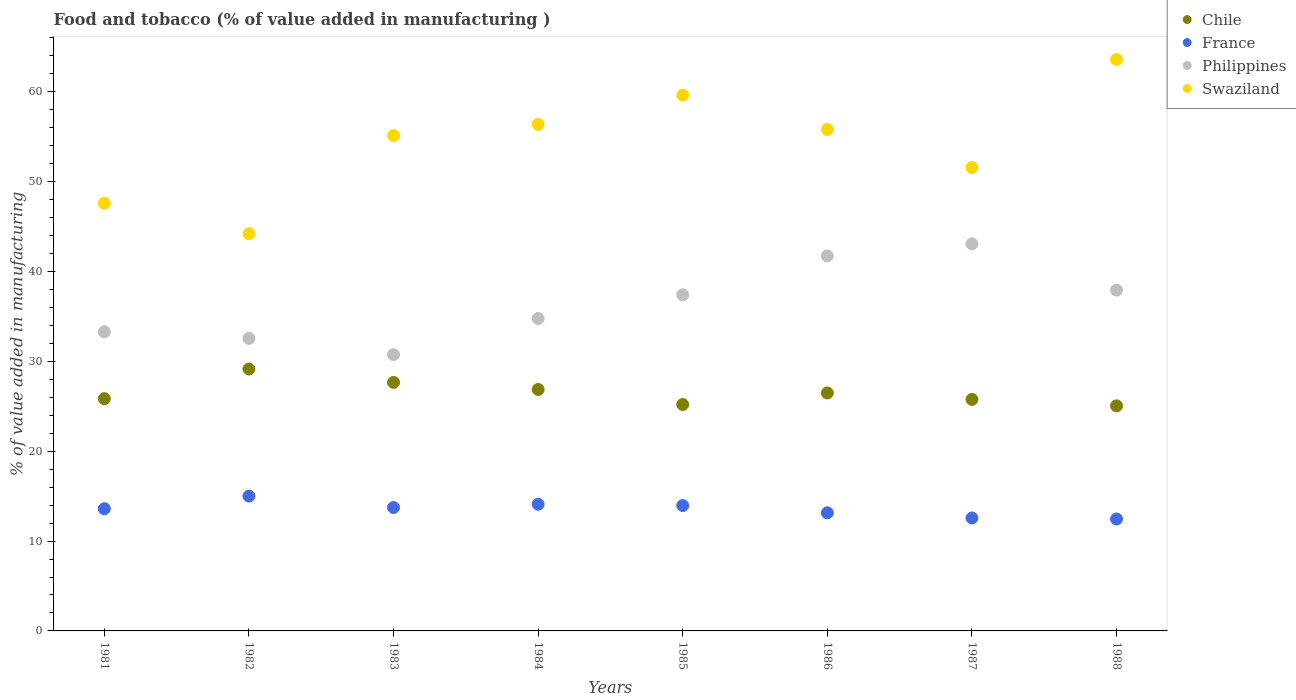How many different coloured dotlines are there?
Keep it short and to the point. 4. What is the value added in manufacturing food and tobacco in Chile in 1981?
Your answer should be compact. 25.85. Across all years, what is the maximum value added in manufacturing food and tobacco in Chile?
Offer a terse response. 29.15. Across all years, what is the minimum value added in manufacturing food and tobacco in France?
Keep it short and to the point. 12.45. In which year was the value added in manufacturing food and tobacco in Chile minimum?
Your answer should be compact. 1988. What is the total value added in manufacturing food and tobacco in France in the graph?
Provide a succinct answer. 108.56. What is the difference between the value added in manufacturing food and tobacco in France in 1986 and that in 1987?
Offer a very short reply. 0.58. What is the difference between the value added in manufacturing food and tobacco in France in 1984 and the value added in manufacturing food and tobacco in Swaziland in 1986?
Offer a terse response. -41.71. What is the average value added in manufacturing food and tobacco in Philippines per year?
Offer a very short reply. 36.44. In the year 1988, what is the difference between the value added in manufacturing food and tobacco in France and value added in manufacturing food and tobacco in Swaziland?
Keep it short and to the point. -51.13. What is the ratio of the value added in manufacturing food and tobacco in Chile in 1982 to that in 1983?
Your response must be concise. 1.05. What is the difference between the highest and the second highest value added in manufacturing food and tobacco in Philippines?
Make the answer very short. 1.35. What is the difference between the highest and the lowest value added in manufacturing food and tobacco in Chile?
Provide a succinct answer. 4.1. In how many years, is the value added in manufacturing food and tobacco in France greater than the average value added in manufacturing food and tobacco in France taken over all years?
Provide a succinct answer. 5. Is it the case that in every year, the sum of the value added in manufacturing food and tobacco in Swaziland and value added in manufacturing food and tobacco in France  is greater than the sum of value added in manufacturing food and tobacco in Philippines and value added in manufacturing food and tobacco in Chile?
Give a very brief answer. No. How many dotlines are there?
Keep it short and to the point. 4. How many years are there in the graph?
Make the answer very short. 8. How many legend labels are there?
Your answer should be very brief. 4. What is the title of the graph?
Provide a succinct answer. Food and tobacco (% of value added in manufacturing ). What is the label or title of the Y-axis?
Keep it short and to the point. % of value added in manufacturing. What is the % of value added in manufacturing in Chile in 1981?
Keep it short and to the point. 25.85. What is the % of value added in manufacturing of France in 1981?
Your response must be concise. 13.6. What is the % of value added in manufacturing of Philippines in 1981?
Give a very brief answer. 33.29. What is the % of value added in manufacturing of Swaziland in 1981?
Offer a very short reply. 47.6. What is the % of value added in manufacturing in Chile in 1982?
Offer a very short reply. 29.15. What is the % of value added in manufacturing in France in 1982?
Keep it short and to the point. 15.01. What is the % of value added in manufacturing in Philippines in 1982?
Make the answer very short. 32.56. What is the % of value added in manufacturing of Swaziland in 1982?
Provide a succinct answer. 44.2. What is the % of value added in manufacturing of Chile in 1983?
Provide a short and direct response. 27.66. What is the % of value added in manufacturing in France in 1983?
Make the answer very short. 13.73. What is the % of value added in manufacturing in Philippines in 1983?
Provide a succinct answer. 30.75. What is the % of value added in manufacturing in Swaziland in 1983?
Offer a very short reply. 55.12. What is the % of value added in manufacturing of Chile in 1984?
Offer a very short reply. 26.87. What is the % of value added in manufacturing of France in 1984?
Your response must be concise. 14.1. What is the % of value added in manufacturing in Philippines in 1984?
Give a very brief answer. 34.77. What is the % of value added in manufacturing in Swaziland in 1984?
Provide a short and direct response. 56.37. What is the % of value added in manufacturing of Chile in 1985?
Provide a succinct answer. 25.2. What is the % of value added in manufacturing of France in 1985?
Provide a succinct answer. 13.95. What is the % of value added in manufacturing of Philippines in 1985?
Give a very brief answer. 37.41. What is the % of value added in manufacturing in Swaziland in 1985?
Your answer should be compact. 59.63. What is the % of value added in manufacturing in Chile in 1986?
Your answer should be very brief. 26.48. What is the % of value added in manufacturing of France in 1986?
Offer a very short reply. 13.15. What is the % of value added in manufacturing of Philippines in 1986?
Your answer should be very brief. 41.73. What is the % of value added in manufacturing in Swaziland in 1986?
Make the answer very short. 55.81. What is the % of value added in manufacturing of Chile in 1987?
Keep it short and to the point. 25.76. What is the % of value added in manufacturing of France in 1987?
Your answer should be compact. 12.57. What is the % of value added in manufacturing of Philippines in 1987?
Provide a short and direct response. 43.08. What is the % of value added in manufacturing of Swaziland in 1987?
Your response must be concise. 51.57. What is the % of value added in manufacturing of Chile in 1988?
Offer a very short reply. 25.05. What is the % of value added in manufacturing in France in 1988?
Provide a succinct answer. 12.45. What is the % of value added in manufacturing in Philippines in 1988?
Your response must be concise. 37.93. What is the % of value added in manufacturing in Swaziland in 1988?
Provide a succinct answer. 63.59. Across all years, what is the maximum % of value added in manufacturing in Chile?
Your response must be concise. 29.15. Across all years, what is the maximum % of value added in manufacturing in France?
Your answer should be compact. 15.01. Across all years, what is the maximum % of value added in manufacturing of Philippines?
Offer a very short reply. 43.08. Across all years, what is the maximum % of value added in manufacturing in Swaziland?
Provide a succinct answer. 63.59. Across all years, what is the minimum % of value added in manufacturing in Chile?
Offer a very short reply. 25.05. Across all years, what is the minimum % of value added in manufacturing in France?
Provide a succinct answer. 12.45. Across all years, what is the minimum % of value added in manufacturing of Philippines?
Offer a terse response. 30.75. Across all years, what is the minimum % of value added in manufacturing of Swaziland?
Give a very brief answer. 44.2. What is the total % of value added in manufacturing of Chile in the graph?
Keep it short and to the point. 212.02. What is the total % of value added in manufacturing of France in the graph?
Provide a short and direct response. 108.56. What is the total % of value added in manufacturing of Philippines in the graph?
Make the answer very short. 291.52. What is the total % of value added in manufacturing of Swaziland in the graph?
Provide a succinct answer. 433.88. What is the difference between the % of value added in manufacturing of Chile in 1981 and that in 1982?
Keep it short and to the point. -3.3. What is the difference between the % of value added in manufacturing of France in 1981 and that in 1982?
Ensure brevity in your answer.  -1.41. What is the difference between the % of value added in manufacturing in Philippines in 1981 and that in 1982?
Give a very brief answer. 0.73. What is the difference between the % of value added in manufacturing in Swaziland in 1981 and that in 1982?
Provide a short and direct response. 3.4. What is the difference between the % of value added in manufacturing of Chile in 1981 and that in 1983?
Offer a terse response. -1.81. What is the difference between the % of value added in manufacturing in France in 1981 and that in 1983?
Keep it short and to the point. -0.13. What is the difference between the % of value added in manufacturing of Philippines in 1981 and that in 1983?
Provide a succinct answer. 2.55. What is the difference between the % of value added in manufacturing in Swaziland in 1981 and that in 1983?
Your answer should be compact. -7.53. What is the difference between the % of value added in manufacturing in Chile in 1981 and that in 1984?
Ensure brevity in your answer.  -1.02. What is the difference between the % of value added in manufacturing in Philippines in 1981 and that in 1984?
Your answer should be compact. -1.48. What is the difference between the % of value added in manufacturing of Swaziland in 1981 and that in 1984?
Make the answer very short. -8.77. What is the difference between the % of value added in manufacturing of Chile in 1981 and that in 1985?
Ensure brevity in your answer.  0.65. What is the difference between the % of value added in manufacturing in France in 1981 and that in 1985?
Your answer should be very brief. -0.35. What is the difference between the % of value added in manufacturing of Philippines in 1981 and that in 1985?
Ensure brevity in your answer.  -4.11. What is the difference between the % of value added in manufacturing in Swaziland in 1981 and that in 1985?
Ensure brevity in your answer.  -12.03. What is the difference between the % of value added in manufacturing in Chile in 1981 and that in 1986?
Ensure brevity in your answer.  -0.64. What is the difference between the % of value added in manufacturing in France in 1981 and that in 1986?
Your answer should be very brief. 0.46. What is the difference between the % of value added in manufacturing of Philippines in 1981 and that in 1986?
Keep it short and to the point. -8.44. What is the difference between the % of value added in manufacturing of Swaziland in 1981 and that in 1986?
Provide a short and direct response. -8.21. What is the difference between the % of value added in manufacturing in Chile in 1981 and that in 1987?
Provide a succinct answer. 0.08. What is the difference between the % of value added in manufacturing of France in 1981 and that in 1987?
Offer a very short reply. 1.03. What is the difference between the % of value added in manufacturing of Philippines in 1981 and that in 1987?
Ensure brevity in your answer.  -9.79. What is the difference between the % of value added in manufacturing of Swaziland in 1981 and that in 1987?
Ensure brevity in your answer.  -3.97. What is the difference between the % of value added in manufacturing of Chile in 1981 and that in 1988?
Your answer should be very brief. 0.8. What is the difference between the % of value added in manufacturing in France in 1981 and that in 1988?
Keep it short and to the point. 1.15. What is the difference between the % of value added in manufacturing in Philippines in 1981 and that in 1988?
Ensure brevity in your answer.  -4.64. What is the difference between the % of value added in manufacturing of Swaziland in 1981 and that in 1988?
Offer a terse response. -15.99. What is the difference between the % of value added in manufacturing in Chile in 1982 and that in 1983?
Your answer should be very brief. 1.49. What is the difference between the % of value added in manufacturing of France in 1982 and that in 1983?
Provide a succinct answer. 1.28. What is the difference between the % of value added in manufacturing in Philippines in 1982 and that in 1983?
Offer a terse response. 1.81. What is the difference between the % of value added in manufacturing in Swaziland in 1982 and that in 1983?
Give a very brief answer. -10.93. What is the difference between the % of value added in manufacturing of Chile in 1982 and that in 1984?
Ensure brevity in your answer.  2.28. What is the difference between the % of value added in manufacturing of France in 1982 and that in 1984?
Provide a succinct answer. 0.91. What is the difference between the % of value added in manufacturing in Philippines in 1982 and that in 1984?
Make the answer very short. -2.21. What is the difference between the % of value added in manufacturing of Swaziland in 1982 and that in 1984?
Provide a short and direct response. -12.17. What is the difference between the % of value added in manufacturing in Chile in 1982 and that in 1985?
Offer a terse response. 3.95. What is the difference between the % of value added in manufacturing of France in 1982 and that in 1985?
Provide a succinct answer. 1.06. What is the difference between the % of value added in manufacturing of Philippines in 1982 and that in 1985?
Keep it short and to the point. -4.85. What is the difference between the % of value added in manufacturing in Swaziland in 1982 and that in 1985?
Your response must be concise. -15.43. What is the difference between the % of value added in manufacturing in Chile in 1982 and that in 1986?
Provide a short and direct response. 2.66. What is the difference between the % of value added in manufacturing in France in 1982 and that in 1986?
Keep it short and to the point. 1.86. What is the difference between the % of value added in manufacturing of Philippines in 1982 and that in 1986?
Offer a terse response. -9.17. What is the difference between the % of value added in manufacturing of Swaziland in 1982 and that in 1986?
Your response must be concise. -11.61. What is the difference between the % of value added in manufacturing of Chile in 1982 and that in 1987?
Your response must be concise. 3.38. What is the difference between the % of value added in manufacturing in France in 1982 and that in 1987?
Provide a short and direct response. 2.44. What is the difference between the % of value added in manufacturing in Philippines in 1982 and that in 1987?
Provide a short and direct response. -10.52. What is the difference between the % of value added in manufacturing of Swaziland in 1982 and that in 1987?
Provide a short and direct response. -7.37. What is the difference between the % of value added in manufacturing of Chile in 1982 and that in 1988?
Your response must be concise. 4.1. What is the difference between the % of value added in manufacturing of France in 1982 and that in 1988?
Ensure brevity in your answer.  2.55. What is the difference between the % of value added in manufacturing in Philippines in 1982 and that in 1988?
Your answer should be very brief. -5.37. What is the difference between the % of value added in manufacturing of Swaziland in 1982 and that in 1988?
Keep it short and to the point. -19.39. What is the difference between the % of value added in manufacturing of Chile in 1983 and that in 1984?
Make the answer very short. 0.79. What is the difference between the % of value added in manufacturing in France in 1983 and that in 1984?
Offer a very short reply. -0.37. What is the difference between the % of value added in manufacturing in Philippines in 1983 and that in 1984?
Make the answer very short. -4.02. What is the difference between the % of value added in manufacturing of Swaziland in 1983 and that in 1984?
Give a very brief answer. -1.25. What is the difference between the % of value added in manufacturing in Chile in 1983 and that in 1985?
Make the answer very short. 2.46. What is the difference between the % of value added in manufacturing in France in 1983 and that in 1985?
Offer a terse response. -0.22. What is the difference between the % of value added in manufacturing of Philippines in 1983 and that in 1985?
Give a very brief answer. -6.66. What is the difference between the % of value added in manufacturing of Swaziland in 1983 and that in 1985?
Make the answer very short. -4.5. What is the difference between the % of value added in manufacturing in Chile in 1983 and that in 1986?
Provide a succinct answer. 1.18. What is the difference between the % of value added in manufacturing in France in 1983 and that in 1986?
Your answer should be compact. 0.59. What is the difference between the % of value added in manufacturing in Philippines in 1983 and that in 1986?
Provide a short and direct response. -10.99. What is the difference between the % of value added in manufacturing in Swaziland in 1983 and that in 1986?
Keep it short and to the point. -0.68. What is the difference between the % of value added in manufacturing of Chile in 1983 and that in 1987?
Your answer should be very brief. 1.9. What is the difference between the % of value added in manufacturing of France in 1983 and that in 1987?
Your answer should be compact. 1.17. What is the difference between the % of value added in manufacturing in Philippines in 1983 and that in 1987?
Provide a succinct answer. -12.34. What is the difference between the % of value added in manufacturing in Swaziland in 1983 and that in 1987?
Ensure brevity in your answer.  3.55. What is the difference between the % of value added in manufacturing of Chile in 1983 and that in 1988?
Provide a succinct answer. 2.61. What is the difference between the % of value added in manufacturing in France in 1983 and that in 1988?
Provide a short and direct response. 1.28. What is the difference between the % of value added in manufacturing in Philippines in 1983 and that in 1988?
Ensure brevity in your answer.  -7.18. What is the difference between the % of value added in manufacturing of Swaziland in 1983 and that in 1988?
Your answer should be compact. -8.47. What is the difference between the % of value added in manufacturing in Chile in 1984 and that in 1985?
Your response must be concise. 1.67. What is the difference between the % of value added in manufacturing in France in 1984 and that in 1985?
Make the answer very short. 0.15. What is the difference between the % of value added in manufacturing of Philippines in 1984 and that in 1985?
Your response must be concise. -2.64. What is the difference between the % of value added in manufacturing in Swaziland in 1984 and that in 1985?
Keep it short and to the point. -3.26. What is the difference between the % of value added in manufacturing of Chile in 1984 and that in 1986?
Your answer should be very brief. 0.39. What is the difference between the % of value added in manufacturing of France in 1984 and that in 1986?
Provide a short and direct response. 0.96. What is the difference between the % of value added in manufacturing in Philippines in 1984 and that in 1986?
Give a very brief answer. -6.96. What is the difference between the % of value added in manufacturing in Swaziland in 1984 and that in 1986?
Offer a terse response. 0.56. What is the difference between the % of value added in manufacturing of Chile in 1984 and that in 1987?
Your answer should be compact. 1.11. What is the difference between the % of value added in manufacturing of France in 1984 and that in 1987?
Your answer should be compact. 1.53. What is the difference between the % of value added in manufacturing in Philippines in 1984 and that in 1987?
Offer a terse response. -8.31. What is the difference between the % of value added in manufacturing in Swaziland in 1984 and that in 1987?
Keep it short and to the point. 4.8. What is the difference between the % of value added in manufacturing of Chile in 1984 and that in 1988?
Ensure brevity in your answer.  1.82. What is the difference between the % of value added in manufacturing of France in 1984 and that in 1988?
Provide a short and direct response. 1.65. What is the difference between the % of value added in manufacturing of Philippines in 1984 and that in 1988?
Your answer should be compact. -3.16. What is the difference between the % of value added in manufacturing of Swaziland in 1984 and that in 1988?
Ensure brevity in your answer.  -7.22. What is the difference between the % of value added in manufacturing of Chile in 1985 and that in 1986?
Provide a short and direct response. -1.29. What is the difference between the % of value added in manufacturing in France in 1985 and that in 1986?
Make the answer very short. 0.81. What is the difference between the % of value added in manufacturing in Philippines in 1985 and that in 1986?
Keep it short and to the point. -4.33. What is the difference between the % of value added in manufacturing of Swaziland in 1985 and that in 1986?
Your answer should be compact. 3.82. What is the difference between the % of value added in manufacturing in Chile in 1985 and that in 1987?
Give a very brief answer. -0.57. What is the difference between the % of value added in manufacturing of France in 1985 and that in 1987?
Keep it short and to the point. 1.38. What is the difference between the % of value added in manufacturing of Philippines in 1985 and that in 1987?
Provide a short and direct response. -5.68. What is the difference between the % of value added in manufacturing in Swaziland in 1985 and that in 1987?
Your response must be concise. 8.06. What is the difference between the % of value added in manufacturing in Chile in 1985 and that in 1988?
Your response must be concise. 0.15. What is the difference between the % of value added in manufacturing in France in 1985 and that in 1988?
Your response must be concise. 1.5. What is the difference between the % of value added in manufacturing in Philippines in 1985 and that in 1988?
Ensure brevity in your answer.  -0.52. What is the difference between the % of value added in manufacturing in Swaziland in 1985 and that in 1988?
Keep it short and to the point. -3.96. What is the difference between the % of value added in manufacturing in Chile in 1986 and that in 1987?
Offer a very short reply. 0.72. What is the difference between the % of value added in manufacturing of France in 1986 and that in 1987?
Your response must be concise. 0.58. What is the difference between the % of value added in manufacturing of Philippines in 1986 and that in 1987?
Your response must be concise. -1.35. What is the difference between the % of value added in manufacturing of Swaziland in 1986 and that in 1987?
Your response must be concise. 4.24. What is the difference between the % of value added in manufacturing of Chile in 1986 and that in 1988?
Give a very brief answer. 1.44. What is the difference between the % of value added in manufacturing in France in 1986 and that in 1988?
Your answer should be compact. 0.69. What is the difference between the % of value added in manufacturing in Philippines in 1986 and that in 1988?
Offer a very short reply. 3.81. What is the difference between the % of value added in manufacturing in Swaziland in 1986 and that in 1988?
Offer a terse response. -7.78. What is the difference between the % of value added in manufacturing of Chile in 1987 and that in 1988?
Give a very brief answer. 0.72. What is the difference between the % of value added in manufacturing in France in 1987 and that in 1988?
Ensure brevity in your answer.  0.11. What is the difference between the % of value added in manufacturing of Philippines in 1987 and that in 1988?
Provide a succinct answer. 5.15. What is the difference between the % of value added in manufacturing in Swaziland in 1987 and that in 1988?
Your answer should be compact. -12.02. What is the difference between the % of value added in manufacturing of Chile in 1981 and the % of value added in manufacturing of France in 1982?
Keep it short and to the point. 10.84. What is the difference between the % of value added in manufacturing in Chile in 1981 and the % of value added in manufacturing in Philippines in 1982?
Offer a terse response. -6.71. What is the difference between the % of value added in manufacturing in Chile in 1981 and the % of value added in manufacturing in Swaziland in 1982?
Keep it short and to the point. -18.35. What is the difference between the % of value added in manufacturing in France in 1981 and the % of value added in manufacturing in Philippines in 1982?
Your answer should be very brief. -18.96. What is the difference between the % of value added in manufacturing in France in 1981 and the % of value added in manufacturing in Swaziland in 1982?
Keep it short and to the point. -30.6. What is the difference between the % of value added in manufacturing of Philippines in 1981 and the % of value added in manufacturing of Swaziland in 1982?
Provide a short and direct response. -10.91. What is the difference between the % of value added in manufacturing of Chile in 1981 and the % of value added in manufacturing of France in 1983?
Give a very brief answer. 12.11. What is the difference between the % of value added in manufacturing of Chile in 1981 and the % of value added in manufacturing of Philippines in 1983?
Keep it short and to the point. -4.9. What is the difference between the % of value added in manufacturing of Chile in 1981 and the % of value added in manufacturing of Swaziland in 1983?
Your answer should be very brief. -29.28. What is the difference between the % of value added in manufacturing in France in 1981 and the % of value added in manufacturing in Philippines in 1983?
Your response must be concise. -17.14. What is the difference between the % of value added in manufacturing in France in 1981 and the % of value added in manufacturing in Swaziland in 1983?
Ensure brevity in your answer.  -41.52. What is the difference between the % of value added in manufacturing of Philippines in 1981 and the % of value added in manufacturing of Swaziland in 1983?
Make the answer very short. -21.83. What is the difference between the % of value added in manufacturing in Chile in 1981 and the % of value added in manufacturing in France in 1984?
Keep it short and to the point. 11.75. What is the difference between the % of value added in manufacturing of Chile in 1981 and the % of value added in manufacturing of Philippines in 1984?
Offer a terse response. -8.92. What is the difference between the % of value added in manufacturing of Chile in 1981 and the % of value added in manufacturing of Swaziland in 1984?
Your response must be concise. -30.52. What is the difference between the % of value added in manufacturing of France in 1981 and the % of value added in manufacturing of Philippines in 1984?
Your response must be concise. -21.17. What is the difference between the % of value added in manufacturing in France in 1981 and the % of value added in manufacturing in Swaziland in 1984?
Your answer should be compact. -42.77. What is the difference between the % of value added in manufacturing in Philippines in 1981 and the % of value added in manufacturing in Swaziland in 1984?
Give a very brief answer. -23.08. What is the difference between the % of value added in manufacturing in Chile in 1981 and the % of value added in manufacturing in France in 1985?
Keep it short and to the point. 11.9. What is the difference between the % of value added in manufacturing of Chile in 1981 and the % of value added in manufacturing of Philippines in 1985?
Keep it short and to the point. -11.56. What is the difference between the % of value added in manufacturing in Chile in 1981 and the % of value added in manufacturing in Swaziland in 1985?
Give a very brief answer. -33.78. What is the difference between the % of value added in manufacturing of France in 1981 and the % of value added in manufacturing of Philippines in 1985?
Ensure brevity in your answer.  -23.8. What is the difference between the % of value added in manufacturing of France in 1981 and the % of value added in manufacturing of Swaziland in 1985?
Give a very brief answer. -46.03. What is the difference between the % of value added in manufacturing in Philippines in 1981 and the % of value added in manufacturing in Swaziland in 1985?
Your response must be concise. -26.33. What is the difference between the % of value added in manufacturing in Chile in 1981 and the % of value added in manufacturing in France in 1986?
Keep it short and to the point. 12.7. What is the difference between the % of value added in manufacturing in Chile in 1981 and the % of value added in manufacturing in Philippines in 1986?
Provide a short and direct response. -15.89. What is the difference between the % of value added in manufacturing in Chile in 1981 and the % of value added in manufacturing in Swaziland in 1986?
Offer a terse response. -29.96. What is the difference between the % of value added in manufacturing of France in 1981 and the % of value added in manufacturing of Philippines in 1986?
Provide a succinct answer. -28.13. What is the difference between the % of value added in manufacturing of France in 1981 and the % of value added in manufacturing of Swaziland in 1986?
Give a very brief answer. -42.21. What is the difference between the % of value added in manufacturing of Philippines in 1981 and the % of value added in manufacturing of Swaziland in 1986?
Offer a terse response. -22.52. What is the difference between the % of value added in manufacturing in Chile in 1981 and the % of value added in manufacturing in France in 1987?
Provide a succinct answer. 13.28. What is the difference between the % of value added in manufacturing in Chile in 1981 and the % of value added in manufacturing in Philippines in 1987?
Make the answer very short. -17.23. What is the difference between the % of value added in manufacturing in Chile in 1981 and the % of value added in manufacturing in Swaziland in 1987?
Give a very brief answer. -25.72. What is the difference between the % of value added in manufacturing in France in 1981 and the % of value added in manufacturing in Philippines in 1987?
Your response must be concise. -29.48. What is the difference between the % of value added in manufacturing in France in 1981 and the % of value added in manufacturing in Swaziland in 1987?
Your answer should be compact. -37.97. What is the difference between the % of value added in manufacturing of Philippines in 1981 and the % of value added in manufacturing of Swaziland in 1987?
Make the answer very short. -18.28. What is the difference between the % of value added in manufacturing in Chile in 1981 and the % of value added in manufacturing in France in 1988?
Your answer should be compact. 13.39. What is the difference between the % of value added in manufacturing of Chile in 1981 and the % of value added in manufacturing of Philippines in 1988?
Provide a short and direct response. -12.08. What is the difference between the % of value added in manufacturing of Chile in 1981 and the % of value added in manufacturing of Swaziland in 1988?
Your answer should be very brief. -37.74. What is the difference between the % of value added in manufacturing of France in 1981 and the % of value added in manufacturing of Philippines in 1988?
Your answer should be compact. -24.33. What is the difference between the % of value added in manufacturing of France in 1981 and the % of value added in manufacturing of Swaziland in 1988?
Make the answer very short. -49.99. What is the difference between the % of value added in manufacturing of Philippines in 1981 and the % of value added in manufacturing of Swaziland in 1988?
Make the answer very short. -30.3. What is the difference between the % of value added in manufacturing in Chile in 1982 and the % of value added in manufacturing in France in 1983?
Provide a succinct answer. 15.41. What is the difference between the % of value added in manufacturing of Chile in 1982 and the % of value added in manufacturing of Philippines in 1983?
Offer a terse response. -1.6. What is the difference between the % of value added in manufacturing of Chile in 1982 and the % of value added in manufacturing of Swaziland in 1983?
Ensure brevity in your answer.  -25.98. What is the difference between the % of value added in manufacturing in France in 1982 and the % of value added in manufacturing in Philippines in 1983?
Give a very brief answer. -15.74. What is the difference between the % of value added in manufacturing in France in 1982 and the % of value added in manufacturing in Swaziland in 1983?
Ensure brevity in your answer.  -40.11. What is the difference between the % of value added in manufacturing in Philippines in 1982 and the % of value added in manufacturing in Swaziland in 1983?
Keep it short and to the point. -22.56. What is the difference between the % of value added in manufacturing in Chile in 1982 and the % of value added in manufacturing in France in 1984?
Your answer should be compact. 15.05. What is the difference between the % of value added in manufacturing in Chile in 1982 and the % of value added in manufacturing in Philippines in 1984?
Provide a short and direct response. -5.62. What is the difference between the % of value added in manufacturing in Chile in 1982 and the % of value added in manufacturing in Swaziland in 1984?
Make the answer very short. -27.22. What is the difference between the % of value added in manufacturing in France in 1982 and the % of value added in manufacturing in Philippines in 1984?
Make the answer very short. -19.76. What is the difference between the % of value added in manufacturing in France in 1982 and the % of value added in manufacturing in Swaziland in 1984?
Your answer should be compact. -41.36. What is the difference between the % of value added in manufacturing of Philippines in 1982 and the % of value added in manufacturing of Swaziland in 1984?
Your answer should be very brief. -23.81. What is the difference between the % of value added in manufacturing in Chile in 1982 and the % of value added in manufacturing in France in 1985?
Offer a very short reply. 15.2. What is the difference between the % of value added in manufacturing in Chile in 1982 and the % of value added in manufacturing in Philippines in 1985?
Provide a short and direct response. -8.26. What is the difference between the % of value added in manufacturing in Chile in 1982 and the % of value added in manufacturing in Swaziland in 1985?
Offer a very short reply. -30.48. What is the difference between the % of value added in manufacturing in France in 1982 and the % of value added in manufacturing in Philippines in 1985?
Offer a terse response. -22.4. What is the difference between the % of value added in manufacturing of France in 1982 and the % of value added in manufacturing of Swaziland in 1985?
Offer a very short reply. -44.62. What is the difference between the % of value added in manufacturing of Philippines in 1982 and the % of value added in manufacturing of Swaziland in 1985?
Offer a terse response. -27.07. What is the difference between the % of value added in manufacturing of Chile in 1982 and the % of value added in manufacturing of France in 1986?
Offer a terse response. 16. What is the difference between the % of value added in manufacturing in Chile in 1982 and the % of value added in manufacturing in Philippines in 1986?
Make the answer very short. -12.59. What is the difference between the % of value added in manufacturing in Chile in 1982 and the % of value added in manufacturing in Swaziland in 1986?
Give a very brief answer. -26.66. What is the difference between the % of value added in manufacturing in France in 1982 and the % of value added in manufacturing in Philippines in 1986?
Offer a terse response. -26.73. What is the difference between the % of value added in manufacturing in France in 1982 and the % of value added in manufacturing in Swaziland in 1986?
Offer a terse response. -40.8. What is the difference between the % of value added in manufacturing in Philippines in 1982 and the % of value added in manufacturing in Swaziland in 1986?
Your response must be concise. -23.25. What is the difference between the % of value added in manufacturing of Chile in 1982 and the % of value added in manufacturing of France in 1987?
Provide a short and direct response. 16.58. What is the difference between the % of value added in manufacturing in Chile in 1982 and the % of value added in manufacturing in Philippines in 1987?
Offer a terse response. -13.93. What is the difference between the % of value added in manufacturing in Chile in 1982 and the % of value added in manufacturing in Swaziland in 1987?
Give a very brief answer. -22.42. What is the difference between the % of value added in manufacturing of France in 1982 and the % of value added in manufacturing of Philippines in 1987?
Make the answer very short. -28.07. What is the difference between the % of value added in manufacturing in France in 1982 and the % of value added in manufacturing in Swaziland in 1987?
Ensure brevity in your answer.  -36.56. What is the difference between the % of value added in manufacturing in Philippines in 1982 and the % of value added in manufacturing in Swaziland in 1987?
Ensure brevity in your answer.  -19.01. What is the difference between the % of value added in manufacturing in Chile in 1982 and the % of value added in manufacturing in France in 1988?
Make the answer very short. 16.69. What is the difference between the % of value added in manufacturing in Chile in 1982 and the % of value added in manufacturing in Philippines in 1988?
Your answer should be compact. -8.78. What is the difference between the % of value added in manufacturing in Chile in 1982 and the % of value added in manufacturing in Swaziland in 1988?
Give a very brief answer. -34.44. What is the difference between the % of value added in manufacturing in France in 1982 and the % of value added in manufacturing in Philippines in 1988?
Make the answer very short. -22.92. What is the difference between the % of value added in manufacturing in France in 1982 and the % of value added in manufacturing in Swaziland in 1988?
Offer a very short reply. -48.58. What is the difference between the % of value added in manufacturing in Philippines in 1982 and the % of value added in manufacturing in Swaziland in 1988?
Give a very brief answer. -31.03. What is the difference between the % of value added in manufacturing of Chile in 1983 and the % of value added in manufacturing of France in 1984?
Provide a short and direct response. 13.56. What is the difference between the % of value added in manufacturing in Chile in 1983 and the % of value added in manufacturing in Philippines in 1984?
Give a very brief answer. -7.11. What is the difference between the % of value added in manufacturing in Chile in 1983 and the % of value added in manufacturing in Swaziland in 1984?
Your answer should be compact. -28.71. What is the difference between the % of value added in manufacturing of France in 1983 and the % of value added in manufacturing of Philippines in 1984?
Make the answer very short. -21.04. What is the difference between the % of value added in manufacturing of France in 1983 and the % of value added in manufacturing of Swaziland in 1984?
Offer a very short reply. -42.64. What is the difference between the % of value added in manufacturing in Philippines in 1983 and the % of value added in manufacturing in Swaziland in 1984?
Make the answer very short. -25.62. What is the difference between the % of value added in manufacturing of Chile in 1983 and the % of value added in manufacturing of France in 1985?
Your answer should be very brief. 13.71. What is the difference between the % of value added in manufacturing of Chile in 1983 and the % of value added in manufacturing of Philippines in 1985?
Provide a short and direct response. -9.75. What is the difference between the % of value added in manufacturing in Chile in 1983 and the % of value added in manufacturing in Swaziland in 1985?
Ensure brevity in your answer.  -31.97. What is the difference between the % of value added in manufacturing of France in 1983 and the % of value added in manufacturing of Philippines in 1985?
Your answer should be compact. -23.67. What is the difference between the % of value added in manufacturing of France in 1983 and the % of value added in manufacturing of Swaziland in 1985?
Your answer should be compact. -45.89. What is the difference between the % of value added in manufacturing in Philippines in 1983 and the % of value added in manufacturing in Swaziland in 1985?
Your answer should be compact. -28.88. What is the difference between the % of value added in manufacturing in Chile in 1983 and the % of value added in manufacturing in France in 1986?
Provide a succinct answer. 14.51. What is the difference between the % of value added in manufacturing of Chile in 1983 and the % of value added in manufacturing of Philippines in 1986?
Your answer should be compact. -14.07. What is the difference between the % of value added in manufacturing of Chile in 1983 and the % of value added in manufacturing of Swaziland in 1986?
Your response must be concise. -28.15. What is the difference between the % of value added in manufacturing of France in 1983 and the % of value added in manufacturing of Philippines in 1986?
Your answer should be very brief. -28. What is the difference between the % of value added in manufacturing in France in 1983 and the % of value added in manufacturing in Swaziland in 1986?
Provide a succinct answer. -42.07. What is the difference between the % of value added in manufacturing in Philippines in 1983 and the % of value added in manufacturing in Swaziland in 1986?
Provide a succinct answer. -25.06. What is the difference between the % of value added in manufacturing in Chile in 1983 and the % of value added in manufacturing in France in 1987?
Give a very brief answer. 15.09. What is the difference between the % of value added in manufacturing in Chile in 1983 and the % of value added in manufacturing in Philippines in 1987?
Your answer should be very brief. -15.42. What is the difference between the % of value added in manufacturing of Chile in 1983 and the % of value added in manufacturing of Swaziland in 1987?
Your answer should be compact. -23.91. What is the difference between the % of value added in manufacturing in France in 1983 and the % of value added in manufacturing in Philippines in 1987?
Give a very brief answer. -29.35. What is the difference between the % of value added in manufacturing in France in 1983 and the % of value added in manufacturing in Swaziland in 1987?
Your answer should be compact. -37.83. What is the difference between the % of value added in manufacturing of Philippines in 1983 and the % of value added in manufacturing of Swaziland in 1987?
Provide a succinct answer. -20.82. What is the difference between the % of value added in manufacturing in Chile in 1983 and the % of value added in manufacturing in France in 1988?
Keep it short and to the point. 15.2. What is the difference between the % of value added in manufacturing in Chile in 1983 and the % of value added in manufacturing in Philippines in 1988?
Keep it short and to the point. -10.27. What is the difference between the % of value added in manufacturing of Chile in 1983 and the % of value added in manufacturing of Swaziland in 1988?
Offer a terse response. -35.93. What is the difference between the % of value added in manufacturing of France in 1983 and the % of value added in manufacturing of Philippines in 1988?
Make the answer very short. -24.19. What is the difference between the % of value added in manufacturing of France in 1983 and the % of value added in manufacturing of Swaziland in 1988?
Offer a terse response. -49.86. What is the difference between the % of value added in manufacturing of Philippines in 1983 and the % of value added in manufacturing of Swaziland in 1988?
Give a very brief answer. -32.84. What is the difference between the % of value added in manufacturing of Chile in 1984 and the % of value added in manufacturing of France in 1985?
Provide a short and direct response. 12.92. What is the difference between the % of value added in manufacturing in Chile in 1984 and the % of value added in manufacturing in Philippines in 1985?
Provide a succinct answer. -10.54. What is the difference between the % of value added in manufacturing in Chile in 1984 and the % of value added in manufacturing in Swaziland in 1985?
Ensure brevity in your answer.  -32.76. What is the difference between the % of value added in manufacturing of France in 1984 and the % of value added in manufacturing of Philippines in 1985?
Your answer should be very brief. -23.3. What is the difference between the % of value added in manufacturing of France in 1984 and the % of value added in manufacturing of Swaziland in 1985?
Provide a short and direct response. -45.53. What is the difference between the % of value added in manufacturing in Philippines in 1984 and the % of value added in manufacturing in Swaziland in 1985?
Offer a very short reply. -24.86. What is the difference between the % of value added in manufacturing in Chile in 1984 and the % of value added in manufacturing in France in 1986?
Your answer should be compact. 13.73. What is the difference between the % of value added in manufacturing in Chile in 1984 and the % of value added in manufacturing in Philippines in 1986?
Your answer should be compact. -14.86. What is the difference between the % of value added in manufacturing of Chile in 1984 and the % of value added in manufacturing of Swaziland in 1986?
Provide a short and direct response. -28.94. What is the difference between the % of value added in manufacturing of France in 1984 and the % of value added in manufacturing of Philippines in 1986?
Ensure brevity in your answer.  -27.63. What is the difference between the % of value added in manufacturing in France in 1984 and the % of value added in manufacturing in Swaziland in 1986?
Your answer should be compact. -41.71. What is the difference between the % of value added in manufacturing of Philippines in 1984 and the % of value added in manufacturing of Swaziland in 1986?
Offer a terse response. -21.04. What is the difference between the % of value added in manufacturing in Chile in 1984 and the % of value added in manufacturing in France in 1987?
Make the answer very short. 14.3. What is the difference between the % of value added in manufacturing in Chile in 1984 and the % of value added in manufacturing in Philippines in 1987?
Ensure brevity in your answer.  -16.21. What is the difference between the % of value added in manufacturing of Chile in 1984 and the % of value added in manufacturing of Swaziland in 1987?
Keep it short and to the point. -24.7. What is the difference between the % of value added in manufacturing of France in 1984 and the % of value added in manufacturing of Philippines in 1987?
Ensure brevity in your answer.  -28.98. What is the difference between the % of value added in manufacturing of France in 1984 and the % of value added in manufacturing of Swaziland in 1987?
Your answer should be very brief. -37.47. What is the difference between the % of value added in manufacturing in Philippines in 1984 and the % of value added in manufacturing in Swaziland in 1987?
Your answer should be very brief. -16.8. What is the difference between the % of value added in manufacturing in Chile in 1984 and the % of value added in manufacturing in France in 1988?
Your answer should be compact. 14.42. What is the difference between the % of value added in manufacturing of Chile in 1984 and the % of value added in manufacturing of Philippines in 1988?
Offer a very short reply. -11.06. What is the difference between the % of value added in manufacturing in Chile in 1984 and the % of value added in manufacturing in Swaziland in 1988?
Your response must be concise. -36.72. What is the difference between the % of value added in manufacturing of France in 1984 and the % of value added in manufacturing of Philippines in 1988?
Make the answer very short. -23.83. What is the difference between the % of value added in manufacturing in France in 1984 and the % of value added in manufacturing in Swaziland in 1988?
Ensure brevity in your answer.  -49.49. What is the difference between the % of value added in manufacturing of Philippines in 1984 and the % of value added in manufacturing of Swaziland in 1988?
Make the answer very short. -28.82. What is the difference between the % of value added in manufacturing of Chile in 1985 and the % of value added in manufacturing of France in 1986?
Make the answer very short. 12.05. What is the difference between the % of value added in manufacturing in Chile in 1985 and the % of value added in manufacturing in Philippines in 1986?
Your answer should be compact. -16.54. What is the difference between the % of value added in manufacturing in Chile in 1985 and the % of value added in manufacturing in Swaziland in 1986?
Keep it short and to the point. -30.61. What is the difference between the % of value added in manufacturing of France in 1985 and the % of value added in manufacturing of Philippines in 1986?
Your answer should be very brief. -27.78. What is the difference between the % of value added in manufacturing of France in 1985 and the % of value added in manufacturing of Swaziland in 1986?
Provide a succinct answer. -41.86. What is the difference between the % of value added in manufacturing in Philippines in 1985 and the % of value added in manufacturing in Swaziland in 1986?
Provide a short and direct response. -18.4. What is the difference between the % of value added in manufacturing of Chile in 1985 and the % of value added in manufacturing of France in 1987?
Your response must be concise. 12.63. What is the difference between the % of value added in manufacturing in Chile in 1985 and the % of value added in manufacturing in Philippines in 1987?
Ensure brevity in your answer.  -17.88. What is the difference between the % of value added in manufacturing in Chile in 1985 and the % of value added in manufacturing in Swaziland in 1987?
Your answer should be very brief. -26.37. What is the difference between the % of value added in manufacturing in France in 1985 and the % of value added in manufacturing in Philippines in 1987?
Offer a very short reply. -29.13. What is the difference between the % of value added in manufacturing in France in 1985 and the % of value added in manufacturing in Swaziland in 1987?
Ensure brevity in your answer.  -37.62. What is the difference between the % of value added in manufacturing in Philippines in 1985 and the % of value added in manufacturing in Swaziland in 1987?
Provide a succinct answer. -14.16. What is the difference between the % of value added in manufacturing of Chile in 1985 and the % of value added in manufacturing of France in 1988?
Your answer should be very brief. 12.74. What is the difference between the % of value added in manufacturing in Chile in 1985 and the % of value added in manufacturing in Philippines in 1988?
Keep it short and to the point. -12.73. What is the difference between the % of value added in manufacturing in Chile in 1985 and the % of value added in manufacturing in Swaziland in 1988?
Your answer should be compact. -38.39. What is the difference between the % of value added in manufacturing of France in 1985 and the % of value added in manufacturing of Philippines in 1988?
Offer a very short reply. -23.98. What is the difference between the % of value added in manufacturing of France in 1985 and the % of value added in manufacturing of Swaziland in 1988?
Keep it short and to the point. -49.64. What is the difference between the % of value added in manufacturing of Philippines in 1985 and the % of value added in manufacturing of Swaziland in 1988?
Your response must be concise. -26.18. What is the difference between the % of value added in manufacturing of Chile in 1986 and the % of value added in manufacturing of France in 1987?
Give a very brief answer. 13.91. What is the difference between the % of value added in manufacturing of Chile in 1986 and the % of value added in manufacturing of Philippines in 1987?
Offer a terse response. -16.6. What is the difference between the % of value added in manufacturing of Chile in 1986 and the % of value added in manufacturing of Swaziland in 1987?
Your response must be concise. -25.09. What is the difference between the % of value added in manufacturing in France in 1986 and the % of value added in manufacturing in Philippines in 1987?
Your answer should be compact. -29.94. What is the difference between the % of value added in manufacturing of France in 1986 and the % of value added in manufacturing of Swaziland in 1987?
Give a very brief answer. -38.42. What is the difference between the % of value added in manufacturing of Philippines in 1986 and the % of value added in manufacturing of Swaziland in 1987?
Offer a very short reply. -9.83. What is the difference between the % of value added in manufacturing in Chile in 1986 and the % of value added in manufacturing in France in 1988?
Your answer should be compact. 14.03. What is the difference between the % of value added in manufacturing of Chile in 1986 and the % of value added in manufacturing of Philippines in 1988?
Your answer should be compact. -11.45. What is the difference between the % of value added in manufacturing of Chile in 1986 and the % of value added in manufacturing of Swaziland in 1988?
Keep it short and to the point. -37.11. What is the difference between the % of value added in manufacturing in France in 1986 and the % of value added in manufacturing in Philippines in 1988?
Provide a succinct answer. -24.78. What is the difference between the % of value added in manufacturing of France in 1986 and the % of value added in manufacturing of Swaziland in 1988?
Make the answer very short. -50.44. What is the difference between the % of value added in manufacturing of Philippines in 1986 and the % of value added in manufacturing of Swaziland in 1988?
Make the answer very short. -21.86. What is the difference between the % of value added in manufacturing in Chile in 1987 and the % of value added in manufacturing in France in 1988?
Keep it short and to the point. 13.31. What is the difference between the % of value added in manufacturing in Chile in 1987 and the % of value added in manufacturing in Philippines in 1988?
Make the answer very short. -12.17. What is the difference between the % of value added in manufacturing of Chile in 1987 and the % of value added in manufacturing of Swaziland in 1988?
Keep it short and to the point. -37.83. What is the difference between the % of value added in manufacturing of France in 1987 and the % of value added in manufacturing of Philippines in 1988?
Make the answer very short. -25.36. What is the difference between the % of value added in manufacturing in France in 1987 and the % of value added in manufacturing in Swaziland in 1988?
Provide a short and direct response. -51.02. What is the difference between the % of value added in manufacturing of Philippines in 1987 and the % of value added in manufacturing of Swaziland in 1988?
Make the answer very short. -20.51. What is the average % of value added in manufacturing in Chile per year?
Give a very brief answer. 26.5. What is the average % of value added in manufacturing of France per year?
Provide a succinct answer. 13.57. What is the average % of value added in manufacturing in Philippines per year?
Ensure brevity in your answer.  36.44. What is the average % of value added in manufacturing in Swaziland per year?
Your answer should be compact. 54.24. In the year 1981, what is the difference between the % of value added in manufacturing in Chile and % of value added in manufacturing in France?
Offer a very short reply. 12.25. In the year 1981, what is the difference between the % of value added in manufacturing in Chile and % of value added in manufacturing in Philippines?
Make the answer very short. -7.45. In the year 1981, what is the difference between the % of value added in manufacturing of Chile and % of value added in manufacturing of Swaziland?
Provide a succinct answer. -21.75. In the year 1981, what is the difference between the % of value added in manufacturing in France and % of value added in manufacturing in Philippines?
Provide a succinct answer. -19.69. In the year 1981, what is the difference between the % of value added in manufacturing in France and % of value added in manufacturing in Swaziland?
Your response must be concise. -34. In the year 1981, what is the difference between the % of value added in manufacturing of Philippines and % of value added in manufacturing of Swaziland?
Offer a terse response. -14.3. In the year 1982, what is the difference between the % of value added in manufacturing of Chile and % of value added in manufacturing of France?
Give a very brief answer. 14.14. In the year 1982, what is the difference between the % of value added in manufacturing of Chile and % of value added in manufacturing of Philippines?
Keep it short and to the point. -3.41. In the year 1982, what is the difference between the % of value added in manufacturing in Chile and % of value added in manufacturing in Swaziland?
Ensure brevity in your answer.  -15.05. In the year 1982, what is the difference between the % of value added in manufacturing in France and % of value added in manufacturing in Philippines?
Keep it short and to the point. -17.55. In the year 1982, what is the difference between the % of value added in manufacturing of France and % of value added in manufacturing of Swaziland?
Keep it short and to the point. -29.19. In the year 1982, what is the difference between the % of value added in manufacturing in Philippines and % of value added in manufacturing in Swaziland?
Make the answer very short. -11.64. In the year 1983, what is the difference between the % of value added in manufacturing of Chile and % of value added in manufacturing of France?
Your answer should be very brief. 13.93. In the year 1983, what is the difference between the % of value added in manufacturing in Chile and % of value added in manufacturing in Philippines?
Provide a succinct answer. -3.09. In the year 1983, what is the difference between the % of value added in manufacturing of Chile and % of value added in manufacturing of Swaziland?
Your answer should be compact. -27.46. In the year 1983, what is the difference between the % of value added in manufacturing of France and % of value added in manufacturing of Philippines?
Your response must be concise. -17.01. In the year 1983, what is the difference between the % of value added in manufacturing in France and % of value added in manufacturing in Swaziland?
Make the answer very short. -41.39. In the year 1983, what is the difference between the % of value added in manufacturing of Philippines and % of value added in manufacturing of Swaziland?
Your response must be concise. -24.38. In the year 1984, what is the difference between the % of value added in manufacturing of Chile and % of value added in manufacturing of France?
Make the answer very short. 12.77. In the year 1984, what is the difference between the % of value added in manufacturing in Chile and % of value added in manufacturing in Philippines?
Your answer should be very brief. -7.9. In the year 1984, what is the difference between the % of value added in manufacturing of Chile and % of value added in manufacturing of Swaziland?
Your answer should be very brief. -29.5. In the year 1984, what is the difference between the % of value added in manufacturing of France and % of value added in manufacturing of Philippines?
Offer a very short reply. -20.67. In the year 1984, what is the difference between the % of value added in manufacturing of France and % of value added in manufacturing of Swaziland?
Offer a terse response. -42.27. In the year 1984, what is the difference between the % of value added in manufacturing in Philippines and % of value added in manufacturing in Swaziland?
Provide a short and direct response. -21.6. In the year 1985, what is the difference between the % of value added in manufacturing in Chile and % of value added in manufacturing in France?
Keep it short and to the point. 11.25. In the year 1985, what is the difference between the % of value added in manufacturing of Chile and % of value added in manufacturing of Philippines?
Ensure brevity in your answer.  -12.21. In the year 1985, what is the difference between the % of value added in manufacturing in Chile and % of value added in manufacturing in Swaziland?
Provide a short and direct response. -34.43. In the year 1985, what is the difference between the % of value added in manufacturing in France and % of value added in manufacturing in Philippines?
Make the answer very short. -23.45. In the year 1985, what is the difference between the % of value added in manufacturing of France and % of value added in manufacturing of Swaziland?
Offer a terse response. -45.68. In the year 1985, what is the difference between the % of value added in manufacturing in Philippines and % of value added in manufacturing in Swaziland?
Offer a terse response. -22.22. In the year 1986, what is the difference between the % of value added in manufacturing of Chile and % of value added in manufacturing of France?
Offer a terse response. 13.34. In the year 1986, what is the difference between the % of value added in manufacturing of Chile and % of value added in manufacturing of Philippines?
Ensure brevity in your answer.  -15.25. In the year 1986, what is the difference between the % of value added in manufacturing of Chile and % of value added in manufacturing of Swaziland?
Ensure brevity in your answer.  -29.32. In the year 1986, what is the difference between the % of value added in manufacturing in France and % of value added in manufacturing in Philippines?
Provide a succinct answer. -28.59. In the year 1986, what is the difference between the % of value added in manufacturing of France and % of value added in manufacturing of Swaziland?
Offer a very short reply. -42.66. In the year 1986, what is the difference between the % of value added in manufacturing of Philippines and % of value added in manufacturing of Swaziland?
Ensure brevity in your answer.  -14.07. In the year 1987, what is the difference between the % of value added in manufacturing of Chile and % of value added in manufacturing of France?
Provide a succinct answer. 13.2. In the year 1987, what is the difference between the % of value added in manufacturing in Chile and % of value added in manufacturing in Philippines?
Give a very brief answer. -17.32. In the year 1987, what is the difference between the % of value added in manufacturing in Chile and % of value added in manufacturing in Swaziland?
Give a very brief answer. -25.81. In the year 1987, what is the difference between the % of value added in manufacturing of France and % of value added in manufacturing of Philippines?
Provide a short and direct response. -30.51. In the year 1987, what is the difference between the % of value added in manufacturing in France and % of value added in manufacturing in Swaziland?
Make the answer very short. -39. In the year 1987, what is the difference between the % of value added in manufacturing in Philippines and % of value added in manufacturing in Swaziland?
Offer a terse response. -8.49. In the year 1988, what is the difference between the % of value added in manufacturing in Chile and % of value added in manufacturing in France?
Ensure brevity in your answer.  12.59. In the year 1988, what is the difference between the % of value added in manufacturing in Chile and % of value added in manufacturing in Philippines?
Ensure brevity in your answer.  -12.88. In the year 1988, what is the difference between the % of value added in manufacturing of Chile and % of value added in manufacturing of Swaziland?
Offer a terse response. -38.54. In the year 1988, what is the difference between the % of value added in manufacturing of France and % of value added in manufacturing of Philippines?
Your answer should be compact. -25.47. In the year 1988, what is the difference between the % of value added in manufacturing of France and % of value added in manufacturing of Swaziland?
Offer a terse response. -51.13. In the year 1988, what is the difference between the % of value added in manufacturing of Philippines and % of value added in manufacturing of Swaziland?
Your answer should be very brief. -25.66. What is the ratio of the % of value added in manufacturing of Chile in 1981 to that in 1982?
Provide a succinct answer. 0.89. What is the ratio of the % of value added in manufacturing of France in 1981 to that in 1982?
Your answer should be compact. 0.91. What is the ratio of the % of value added in manufacturing in Philippines in 1981 to that in 1982?
Give a very brief answer. 1.02. What is the ratio of the % of value added in manufacturing of Chile in 1981 to that in 1983?
Make the answer very short. 0.93. What is the ratio of the % of value added in manufacturing in France in 1981 to that in 1983?
Offer a terse response. 0.99. What is the ratio of the % of value added in manufacturing of Philippines in 1981 to that in 1983?
Offer a very short reply. 1.08. What is the ratio of the % of value added in manufacturing in Swaziland in 1981 to that in 1983?
Your answer should be very brief. 0.86. What is the ratio of the % of value added in manufacturing of Chile in 1981 to that in 1984?
Keep it short and to the point. 0.96. What is the ratio of the % of value added in manufacturing in France in 1981 to that in 1984?
Your answer should be compact. 0.96. What is the ratio of the % of value added in manufacturing of Philippines in 1981 to that in 1984?
Make the answer very short. 0.96. What is the ratio of the % of value added in manufacturing in Swaziland in 1981 to that in 1984?
Ensure brevity in your answer.  0.84. What is the ratio of the % of value added in manufacturing in Chile in 1981 to that in 1985?
Give a very brief answer. 1.03. What is the ratio of the % of value added in manufacturing of France in 1981 to that in 1985?
Keep it short and to the point. 0.97. What is the ratio of the % of value added in manufacturing in Philippines in 1981 to that in 1985?
Make the answer very short. 0.89. What is the ratio of the % of value added in manufacturing in Swaziland in 1981 to that in 1985?
Provide a succinct answer. 0.8. What is the ratio of the % of value added in manufacturing in France in 1981 to that in 1986?
Offer a very short reply. 1.03. What is the ratio of the % of value added in manufacturing in Philippines in 1981 to that in 1986?
Your answer should be very brief. 0.8. What is the ratio of the % of value added in manufacturing in Swaziland in 1981 to that in 1986?
Give a very brief answer. 0.85. What is the ratio of the % of value added in manufacturing of Chile in 1981 to that in 1987?
Give a very brief answer. 1. What is the ratio of the % of value added in manufacturing in France in 1981 to that in 1987?
Provide a short and direct response. 1.08. What is the ratio of the % of value added in manufacturing in Philippines in 1981 to that in 1987?
Make the answer very short. 0.77. What is the ratio of the % of value added in manufacturing in Swaziland in 1981 to that in 1987?
Your answer should be very brief. 0.92. What is the ratio of the % of value added in manufacturing in Chile in 1981 to that in 1988?
Offer a terse response. 1.03. What is the ratio of the % of value added in manufacturing in France in 1981 to that in 1988?
Keep it short and to the point. 1.09. What is the ratio of the % of value added in manufacturing in Philippines in 1981 to that in 1988?
Your answer should be very brief. 0.88. What is the ratio of the % of value added in manufacturing in Swaziland in 1981 to that in 1988?
Keep it short and to the point. 0.75. What is the ratio of the % of value added in manufacturing in Chile in 1982 to that in 1983?
Offer a very short reply. 1.05. What is the ratio of the % of value added in manufacturing in France in 1982 to that in 1983?
Make the answer very short. 1.09. What is the ratio of the % of value added in manufacturing in Philippines in 1982 to that in 1983?
Your answer should be very brief. 1.06. What is the ratio of the % of value added in manufacturing in Swaziland in 1982 to that in 1983?
Give a very brief answer. 0.8. What is the ratio of the % of value added in manufacturing of Chile in 1982 to that in 1984?
Your answer should be compact. 1.08. What is the ratio of the % of value added in manufacturing of France in 1982 to that in 1984?
Provide a short and direct response. 1.06. What is the ratio of the % of value added in manufacturing of Philippines in 1982 to that in 1984?
Ensure brevity in your answer.  0.94. What is the ratio of the % of value added in manufacturing in Swaziland in 1982 to that in 1984?
Give a very brief answer. 0.78. What is the ratio of the % of value added in manufacturing of Chile in 1982 to that in 1985?
Ensure brevity in your answer.  1.16. What is the ratio of the % of value added in manufacturing of France in 1982 to that in 1985?
Keep it short and to the point. 1.08. What is the ratio of the % of value added in manufacturing of Philippines in 1982 to that in 1985?
Provide a short and direct response. 0.87. What is the ratio of the % of value added in manufacturing of Swaziland in 1982 to that in 1985?
Offer a very short reply. 0.74. What is the ratio of the % of value added in manufacturing in Chile in 1982 to that in 1986?
Provide a short and direct response. 1.1. What is the ratio of the % of value added in manufacturing of France in 1982 to that in 1986?
Ensure brevity in your answer.  1.14. What is the ratio of the % of value added in manufacturing of Philippines in 1982 to that in 1986?
Your response must be concise. 0.78. What is the ratio of the % of value added in manufacturing of Swaziland in 1982 to that in 1986?
Offer a terse response. 0.79. What is the ratio of the % of value added in manufacturing of Chile in 1982 to that in 1987?
Offer a terse response. 1.13. What is the ratio of the % of value added in manufacturing in France in 1982 to that in 1987?
Offer a terse response. 1.19. What is the ratio of the % of value added in manufacturing of Philippines in 1982 to that in 1987?
Make the answer very short. 0.76. What is the ratio of the % of value added in manufacturing in Chile in 1982 to that in 1988?
Your response must be concise. 1.16. What is the ratio of the % of value added in manufacturing of France in 1982 to that in 1988?
Make the answer very short. 1.21. What is the ratio of the % of value added in manufacturing of Philippines in 1982 to that in 1988?
Provide a succinct answer. 0.86. What is the ratio of the % of value added in manufacturing of Swaziland in 1982 to that in 1988?
Keep it short and to the point. 0.7. What is the ratio of the % of value added in manufacturing of Chile in 1983 to that in 1984?
Give a very brief answer. 1.03. What is the ratio of the % of value added in manufacturing of France in 1983 to that in 1984?
Make the answer very short. 0.97. What is the ratio of the % of value added in manufacturing of Philippines in 1983 to that in 1984?
Your answer should be compact. 0.88. What is the ratio of the % of value added in manufacturing in Swaziland in 1983 to that in 1984?
Provide a succinct answer. 0.98. What is the ratio of the % of value added in manufacturing of Chile in 1983 to that in 1985?
Provide a short and direct response. 1.1. What is the ratio of the % of value added in manufacturing of France in 1983 to that in 1985?
Keep it short and to the point. 0.98. What is the ratio of the % of value added in manufacturing of Philippines in 1983 to that in 1985?
Your response must be concise. 0.82. What is the ratio of the % of value added in manufacturing of Swaziland in 1983 to that in 1985?
Your answer should be very brief. 0.92. What is the ratio of the % of value added in manufacturing in Chile in 1983 to that in 1986?
Your answer should be compact. 1.04. What is the ratio of the % of value added in manufacturing in France in 1983 to that in 1986?
Ensure brevity in your answer.  1.04. What is the ratio of the % of value added in manufacturing in Philippines in 1983 to that in 1986?
Your answer should be very brief. 0.74. What is the ratio of the % of value added in manufacturing of Chile in 1983 to that in 1987?
Provide a succinct answer. 1.07. What is the ratio of the % of value added in manufacturing in France in 1983 to that in 1987?
Your answer should be compact. 1.09. What is the ratio of the % of value added in manufacturing in Philippines in 1983 to that in 1987?
Offer a very short reply. 0.71. What is the ratio of the % of value added in manufacturing in Swaziland in 1983 to that in 1987?
Your response must be concise. 1.07. What is the ratio of the % of value added in manufacturing of Chile in 1983 to that in 1988?
Keep it short and to the point. 1.1. What is the ratio of the % of value added in manufacturing of France in 1983 to that in 1988?
Provide a succinct answer. 1.1. What is the ratio of the % of value added in manufacturing in Philippines in 1983 to that in 1988?
Make the answer very short. 0.81. What is the ratio of the % of value added in manufacturing in Swaziland in 1983 to that in 1988?
Your answer should be compact. 0.87. What is the ratio of the % of value added in manufacturing in Chile in 1984 to that in 1985?
Offer a very short reply. 1.07. What is the ratio of the % of value added in manufacturing in France in 1984 to that in 1985?
Provide a short and direct response. 1.01. What is the ratio of the % of value added in manufacturing of Philippines in 1984 to that in 1985?
Ensure brevity in your answer.  0.93. What is the ratio of the % of value added in manufacturing in Swaziland in 1984 to that in 1985?
Give a very brief answer. 0.95. What is the ratio of the % of value added in manufacturing of Chile in 1984 to that in 1986?
Ensure brevity in your answer.  1.01. What is the ratio of the % of value added in manufacturing in France in 1984 to that in 1986?
Make the answer very short. 1.07. What is the ratio of the % of value added in manufacturing of Philippines in 1984 to that in 1986?
Your response must be concise. 0.83. What is the ratio of the % of value added in manufacturing in Swaziland in 1984 to that in 1986?
Ensure brevity in your answer.  1.01. What is the ratio of the % of value added in manufacturing in Chile in 1984 to that in 1987?
Provide a succinct answer. 1.04. What is the ratio of the % of value added in manufacturing of France in 1984 to that in 1987?
Offer a terse response. 1.12. What is the ratio of the % of value added in manufacturing of Philippines in 1984 to that in 1987?
Offer a terse response. 0.81. What is the ratio of the % of value added in manufacturing in Swaziland in 1984 to that in 1987?
Your answer should be compact. 1.09. What is the ratio of the % of value added in manufacturing of Chile in 1984 to that in 1988?
Keep it short and to the point. 1.07. What is the ratio of the % of value added in manufacturing of France in 1984 to that in 1988?
Provide a short and direct response. 1.13. What is the ratio of the % of value added in manufacturing in Swaziland in 1984 to that in 1988?
Ensure brevity in your answer.  0.89. What is the ratio of the % of value added in manufacturing of Chile in 1985 to that in 1986?
Your answer should be compact. 0.95. What is the ratio of the % of value added in manufacturing of France in 1985 to that in 1986?
Keep it short and to the point. 1.06. What is the ratio of the % of value added in manufacturing of Philippines in 1985 to that in 1986?
Your response must be concise. 0.9. What is the ratio of the % of value added in manufacturing in Swaziland in 1985 to that in 1986?
Provide a succinct answer. 1.07. What is the ratio of the % of value added in manufacturing of France in 1985 to that in 1987?
Ensure brevity in your answer.  1.11. What is the ratio of the % of value added in manufacturing of Philippines in 1985 to that in 1987?
Provide a short and direct response. 0.87. What is the ratio of the % of value added in manufacturing of Swaziland in 1985 to that in 1987?
Your answer should be compact. 1.16. What is the ratio of the % of value added in manufacturing in Chile in 1985 to that in 1988?
Make the answer very short. 1.01. What is the ratio of the % of value added in manufacturing of France in 1985 to that in 1988?
Your response must be concise. 1.12. What is the ratio of the % of value added in manufacturing in Philippines in 1985 to that in 1988?
Provide a succinct answer. 0.99. What is the ratio of the % of value added in manufacturing in Swaziland in 1985 to that in 1988?
Provide a succinct answer. 0.94. What is the ratio of the % of value added in manufacturing of Chile in 1986 to that in 1987?
Provide a short and direct response. 1.03. What is the ratio of the % of value added in manufacturing of France in 1986 to that in 1987?
Ensure brevity in your answer.  1.05. What is the ratio of the % of value added in manufacturing in Philippines in 1986 to that in 1987?
Your answer should be very brief. 0.97. What is the ratio of the % of value added in manufacturing in Swaziland in 1986 to that in 1987?
Ensure brevity in your answer.  1.08. What is the ratio of the % of value added in manufacturing of Chile in 1986 to that in 1988?
Keep it short and to the point. 1.06. What is the ratio of the % of value added in manufacturing of France in 1986 to that in 1988?
Make the answer very short. 1.06. What is the ratio of the % of value added in manufacturing in Philippines in 1986 to that in 1988?
Give a very brief answer. 1.1. What is the ratio of the % of value added in manufacturing in Swaziland in 1986 to that in 1988?
Keep it short and to the point. 0.88. What is the ratio of the % of value added in manufacturing in Chile in 1987 to that in 1988?
Ensure brevity in your answer.  1.03. What is the ratio of the % of value added in manufacturing in France in 1987 to that in 1988?
Your answer should be very brief. 1.01. What is the ratio of the % of value added in manufacturing in Philippines in 1987 to that in 1988?
Your answer should be compact. 1.14. What is the ratio of the % of value added in manufacturing of Swaziland in 1987 to that in 1988?
Offer a terse response. 0.81. What is the difference between the highest and the second highest % of value added in manufacturing in Chile?
Offer a very short reply. 1.49. What is the difference between the highest and the second highest % of value added in manufacturing in France?
Offer a very short reply. 0.91. What is the difference between the highest and the second highest % of value added in manufacturing of Philippines?
Give a very brief answer. 1.35. What is the difference between the highest and the second highest % of value added in manufacturing of Swaziland?
Provide a succinct answer. 3.96. What is the difference between the highest and the lowest % of value added in manufacturing of Chile?
Keep it short and to the point. 4.1. What is the difference between the highest and the lowest % of value added in manufacturing of France?
Provide a succinct answer. 2.55. What is the difference between the highest and the lowest % of value added in manufacturing in Philippines?
Offer a terse response. 12.34. What is the difference between the highest and the lowest % of value added in manufacturing in Swaziland?
Provide a short and direct response. 19.39. 